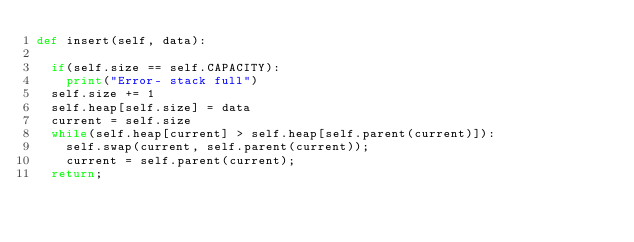<code> <loc_0><loc_0><loc_500><loc_500><_Python_>def insert(self, data):
	
	if(self.size == self.CAPACITY):
		print("Error- stack full")
	self.size += 1
	self.heap[self.size] = data
	current = self.size
	while(self.heap[current] > self.heap[self.parent(current)]):
		self.swap(current, self.parent(current));
		current = self.parent(current);
	return;</code> 